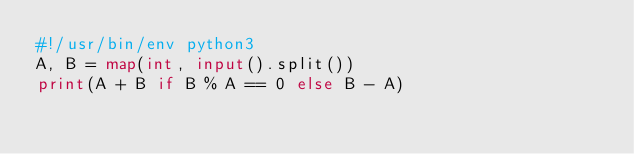<code> <loc_0><loc_0><loc_500><loc_500><_Python_>#!/usr/bin/env python3
A, B = map(int, input().split())
print(A + B if B % A == 0 else B - A)
</code> 